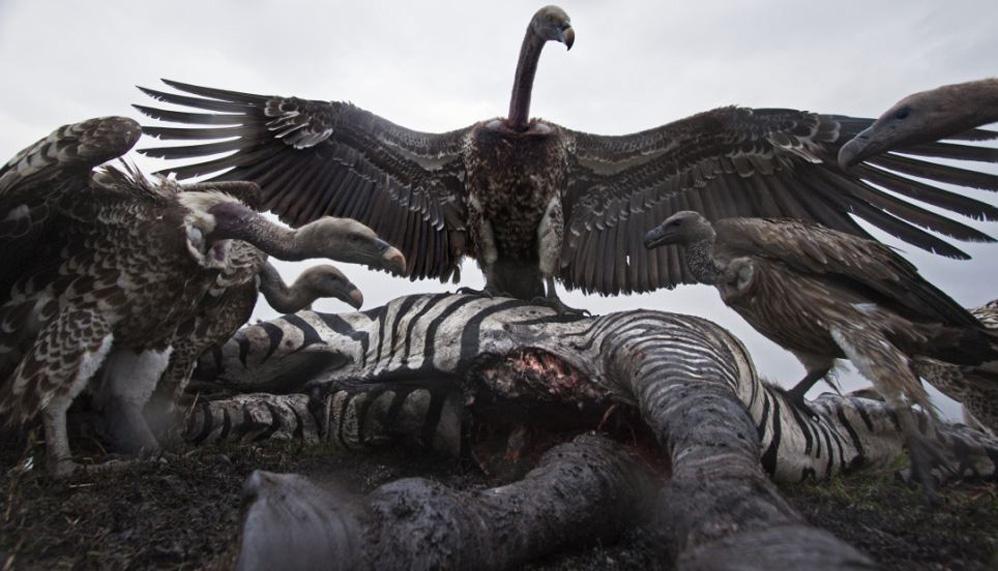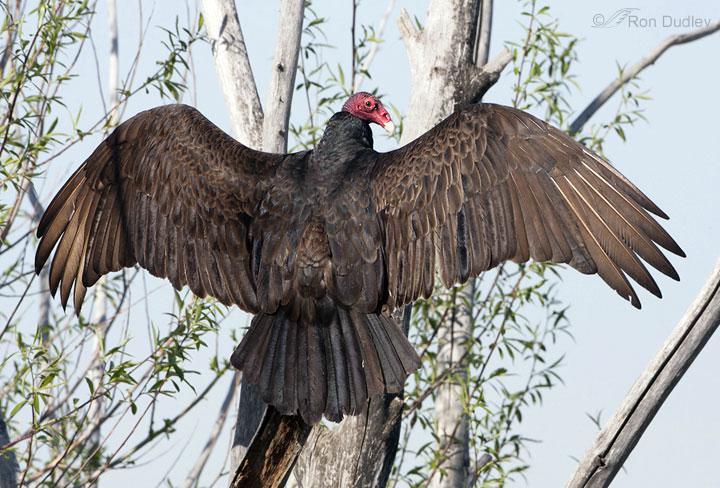The first image is the image on the left, the second image is the image on the right. For the images displayed, is the sentence "One of the birds is perched in a tree branch." factually correct? Answer yes or no. Yes. 